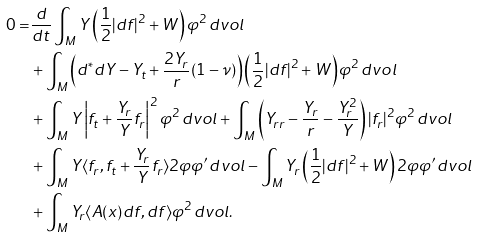<formula> <loc_0><loc_0><loc_500><loc_500>0 = & \frac { d } { d t } \int _ { M } Y \left ( \frac { 1 } { 2 } | d f | ^ { 2 } + W \right ) \varphi ^ { 2 } \, d v o l \\ & + \int _ { M } \left ( d ^ { * } d Y - Y _ { t } + \frac { 2 Y _ { r } } { r } ( 1 - \nu ) \right ) \left ( \frac { 1 } { 2 } | d f | ^ { 2 } + W \right ) \varphi ^ { 2 } \, d v o l \\ & + \int _ { M } Y \left | f _ { t } + \frac { Y _ { r } } { Y } f _ { r } \right | ^ { 2 } \varphi ^ { 2 } \, d v o l + \int _ { M } \left ( Y _ { r r } - \frac { Y _ { r } } { r } - \frac { Y _ { r } ^ { 2 } } { Y } \right ) | f _ { r } | ^ { 2 } \varphi ^ { 2 } \, d v o l \\ & + \int _ { M } Y \langle f _ { r } , f _ { t } + \frac { Y _ { r } } { Y } f _ { r } \rangle 2 \varphi \varphi ^ { \prime } \, d v o l - \int _ { M } Y _ { r } \left ( \frac { 1 } { 2 } | d f | ^ { 2 } + W \right ) 2 \varphi \varphi ^ { \prime } \, d v o l \\ & + \int _ { M } Y _ { r } \langle A ( x ) d f , d f \rangle \varphi ^ { 2 } \, d v o l .</formula> 